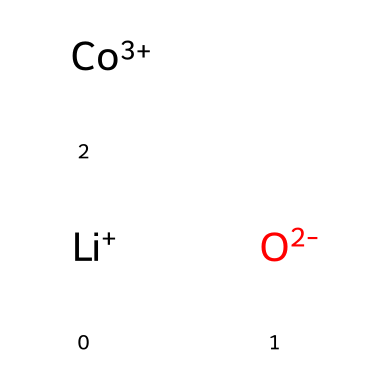What is the total number of atoms in lithium cobalt oxide? In the structure represented by the SMILES, the components are lithium (Li), cobalt (Co), and oxygen (O). Counting these: 1 lithium, 1 cobalt, and 2 oxygens gives a total of 1 + 1 + 2 = 4 atoms.
Answer: 4 What is the oxidation state of cobalt in this structure? The SMILES notation indicates cobalt is represented as Co+3, which directly indicates its oxidation state. Therefore, cobalt has an oxidation state of +3.
Answer: +3 How many oxygen atoms are present in lithium cobalt oxide? From the SMILES representation, there are two 'O' symbols, indicating the presence of two oxygen atoms in the compound.
Answer: 2 What type of solid is lithium cobalt oxide classified as? Lithium cobalt oxide is typically classified as a layered oxide, which is commonly used in battery applications, especially in lithium-ion batteries. This categorizes it as a solid with a specific crystalline structure.
Answer: layered oxide What charge do the lithium and oxygen atoms carry? The SMILES indicate lithium is Li+, meaning it carries a positive charge, while oxygen is illustrated as O-2, indicating it carries a negative charge of two. Thus, lithium carries a +1, and oxygen carries a -2 charge.
Answer: +1, -2 In what type of application is lithium cobalt oxide primarily utilized? Lithium cobalt oxide is primarily used in rechargeable lithium-ion batteries, which make it popular in electronics and electric vehicles. Therefore, its common application is in energy storage devices.
Answer: rechargeable batteries 